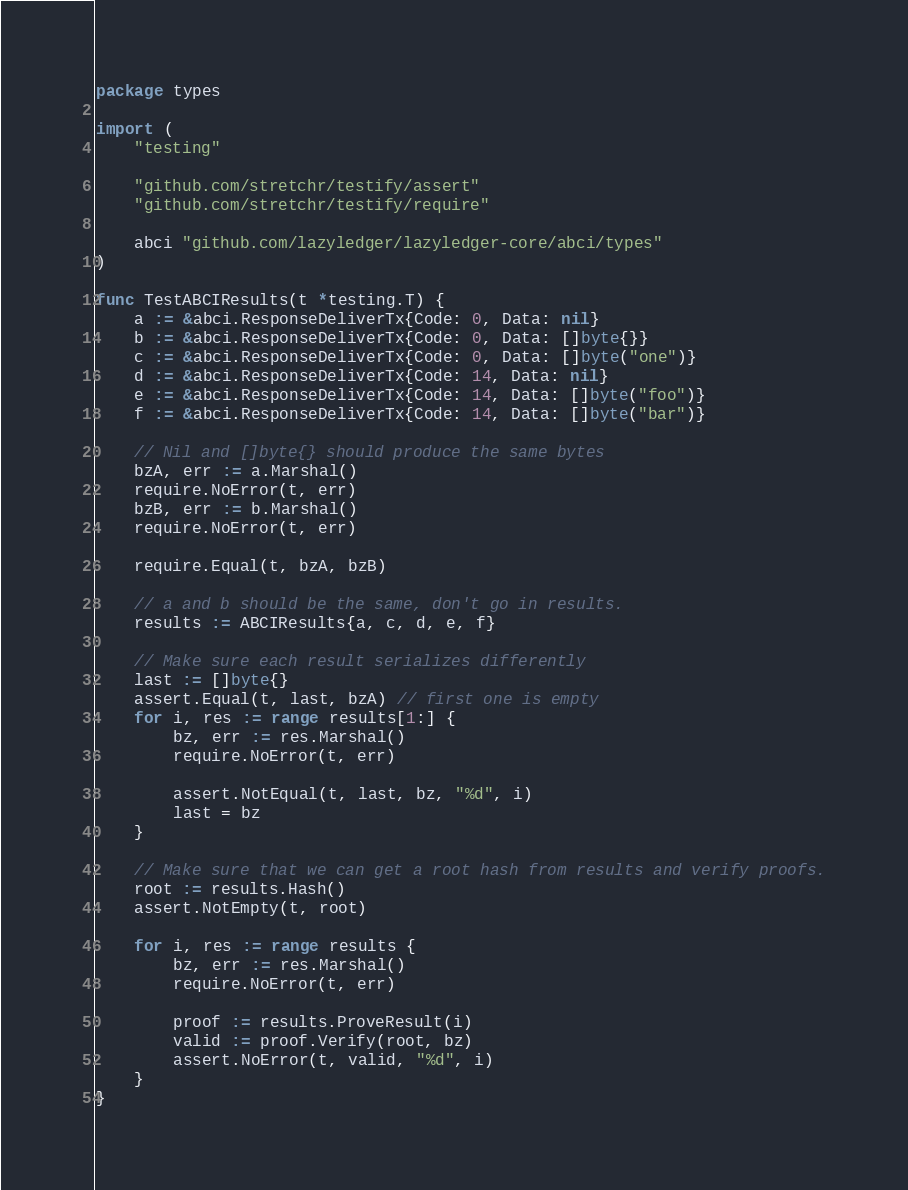Convert code to text. <code><loc_0><loc_0><loc_500><loc_500><_Go_>package types

import (
	"testing"

	"github.com/stretchr/testify/assert"
	"github.com/stretchr/testify/require"

	abci "github.com/lazyledger/lazyledger-core/abci/types"
)

func TestABCIResults(t *testing.T) {
	a := &abci.ResponseDeliverTx{Code: 0, Data: nil}
	b := &abci.ResponseDeliverTx{Code: 0, Data: []byte{}}
	c := &abci.ResponseDeliverTx{Code: 0, Data: []byte("one")}
	d := &abci.ResponseDeliverTx{Code: 14, Data: nil}
	e := &abci.ResponseDeliverTx{Code: 14, Data: []byte("foo")}
	f := &abci.ResponseDeliverTx{Code: 14, Data: []byte("bar")}

	// Nil and []byte{} should produce the same bytes
	bzA, err := a.Marshal()
	require.NoError(t, err)
	bzB, err := b.Marshal()
	require.NoError(t, err)

	require.Equal(t, bzA, bzB)

	// a and b should be the same, don't go in results.
	results := ABCIResults{a, c, d, e, f}

	// Make sure each result serializes differently
	last := []byte{}
	assert.Equal(t, last, bzA) // first one is empty
	for i, res := range results[1:] {
		bz, err := res.Marshal()
		require.NoError(t, err)

		assert.NotEqual(t, last, bz, "%d", i)
		last = bz
	}

	// Make sure that we can get a root hash from results and verify proofs.
	root := results.Hash()
	assert.NotEmpty(t, root)

	for i, res := range results {
		bz, err := res.Marshal()
		require.NoError(t, err)

		proof := results.ProveResult(i)
		valid := proof.Verify(root, bz)
		assert.NoError(t, valid, "%d", i)
	}
}
</code> 